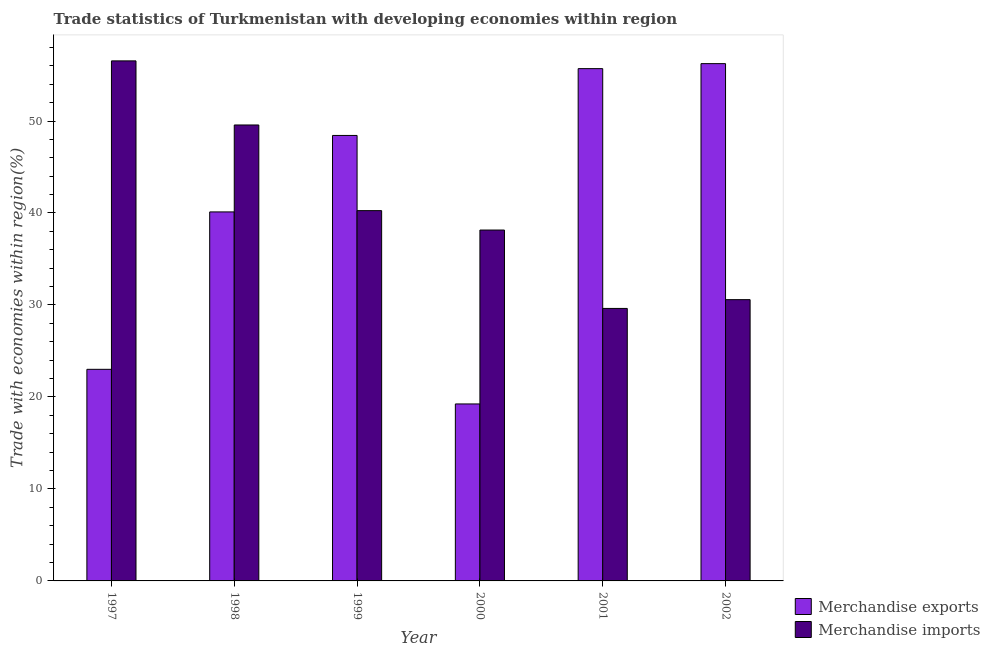How many different coloured bars are there?
Your answer should be very brief. 2. How many groups of bars are there?
Your answer should be very brief. 6. Are the number of bars on each tick of the X-axis equal?
Provide a short and direct response. Yes. What is the merchandise exports in 2000?
Provide a succinct answer. 19.24. Across all years, what is the maximum merchandise exports?
Your answer should be very brief. 56.24. Across all years, what is the minimum merchandise exports?
Your answer should be compact. 19.24. In which year was the merchandise exports minimum?
Provide a short and direct response. 2000. What is the total merchandise imports in the graph?
Offer a very short reply. 244.71. What is the difference between the merchandise exports in 1997 and that in 2001?
Your answer should be compact. -32.69. What is the difference between the merchandise imports in 2000 and the merchandise exports in 1998?
Offer a terse response. -11.42. What is the average merchandise imports per year?
Your answer should be very brief. 40.79. In how many years, is the merchandise imports greater than 46 %?
Ensure brevity in your answer.  2. What is the ratio of the merchandise imports in 1999 to that in 2000?
Your answer should be compact. 1.06. Is the merchandise exports in 1998 less than that in 2002?
Your answer should be compact. Yes. Is the difference between the merchandise imports in 1998 and 1999 greater than the difference between the merchandise exports in 1998 and 1999?
Your response must be concise. No. What is the difference between the highest and the second highest merchandise exports?
Your answer should be compact. 0.54. What is the difference between the highest and the lowest merchandise exports?
Provide a succinct answer. 37. In how many years, is the merchandise exports greater than the average merchandise exports taken over all years?
Your answer should be compact. 3. What does the 1st bar from the left in 2001 represents?
Provide a short and direct response. Merchandise exports. How many bars are there?
Your answer should be very brief. 12. Are all the bars in the graph horizontal?
Your answer should be very brief. No. Are the values on the major ticks of Y-axis written in scientific E-notation?
Your response must be concise. No. Does the graph contain any zero values?
Provide a succinct answer. No. Does the graph contain grids?
Provide a short and direct response. No. How many legend labels are there?
Offer a very short reply. 2. How are the legend labels stacked?
Offer a very short reply. Vertical. What is the title of the graph?
Your answer should be compact. Trade statistics of Turkmenistan with developing economies within region. What is the label or title of the X-axis?
Give a very brief answer. Year. What is the label or title of the Y-axis?
Offer a very short reply. Trade with economies within region(%). What is the Trade with economies within region(%) of Merchandise exports in 1997?
Provide a short and direct response. 23. What is the Trade with economies within region(%) in Merchandise imports in 1997?
Provide a short and direct response. 56.54. What is the Trade with economies within region(%) in Merchandise exports in 1998?
Keep it short and to the point. 40.12. What is the Trade with economies within region(%) in Merchandise imports in 1998?
Your answer should be compact. 49.57. What is the Trade with economies within region(%) in Merchandise exports in 1999?
Keep it short and to the point. 48.43. What is the Trade with economies within region(%) of Merchandise imports in 1999?
Your answer should be very brief. 40.26. What is the Trade with economies within region(%) of Merchandise exports in 2000?
Provide a short and direct response. 19.24. What is the Trade with economies within region(%) in Merchandise imports in 2000?
Your answer should be compact. 38.15. What is the Trade with economies within region(%) in Merchandise exports in 2001?
Your response must be concise. 55.69. What is the Trade with economies within region(%) of Merchandise imports in 2001?
Provide a succinct answer. 29.62. What is the Trade with economies within region(%) in Merchandise exports in 2002?
Provide a short and direct response. 56.24. What is the Trade with economies within region(%) of Merchandise imports in 2002?
Offer a very short reply. 30.58. Across all years, what is the maximum Trade with economies within region(%) in Merchandise exports?
Your answer should be compact. 56.24. Across all years, what is the maximum Trade with economies within region(%) of Merchandise imports?
Your answer should be very brief. 56.54. Across all years, what is the minimum Trade with economies within region(%) in Merchandise exports?
Provide a short and direct response. 19.24. Across all years, what is the minimum Trade with economies within region(%) of Merchandise imports?
Offer a terse response. 29.62. What is the total Trade with economies within region(%) in Merchandise exports in the graph?
Offer a terse response. 242.73. What is the total Trade with economies within region(%) in Merchandise imports in the graph?
Make the answer very short. 244.71. What is the difference between the Trade with economies within region(%) of Merchandise exports in 1997 and that in 1998?
Offer a very short reply. -17.11. What is the difference between the Trade with economies within region(%) of Merchandise imports in 1997 and that in 1998?
Keep it short and to the point. 6.97. What is the difference between the Trade with economies within region(%) in Merchandise exports in 1997 and that in 1999?
Offer a terse response. -25.43. What is the difference between the Trade with economies within region(%) of Merchandise imports in 1997 and that in 1999?
Your response must be concise. 16.28. What is the difference between the Trade with economies within region(%) in Merchandise exports in 1997 and that in 2000?
Make the answer very short. 3.76. What is the difference between the Trade with economies within region(%) in Merchandise imports in 1997 and that in 2000?
Your response must be concise. 18.39. What is the difference between the Trade with economies within region(%) in Merchandise exports in 1997 and that in 2001?
Give a very brief answer. -32.69. What is the difference between the Trade with economies within region(%) in Merchandise imports in 1997 and that in 2001?
Provide a short and direct response. 26.91. What is the difference between the Trade with economies within region(%) in Merchandise exports in 1997 and that in 2002?
Give a very brief answer. -33.23. What is the difference between the Trade with economies within region(%) in Merchandise imports in 1997 and that in 2002?
Provide a short and direct response. 25.96. What is the difference between the Trade with economies within region(%) of Merchandise exports in 1998 and that in 1999?
Provide a succinct answer. -8.31. What is the difference between the Trade with economies within region(%) in Merchandise imports in 1998 and that in 1999?
Provide a short and direct response. 9.31. What is the difference between the Trade with economies within region(%) of Merchandise exports in 1998 and that in 2000?
Your answer should be very brief. 20.88. What is the difference between the Trade with economies within region(%) in Merchandise imports in 1998 and that in 2000?
Ensure brevity in your answer.  11.42. What is the difference between the Trade with economies within region(%) of Merchandise exports in 1998 and that in 2001?
Provide a short and direct response. -15.58. What is the difference between the Trade with economies within region(%) in Merchandise imports in 1998 and that in 2001?
Your answer should be very brief. 19.94. What is the difference between the Trade with economies within region(%) of Merchandise exports in 1998 and that in 2002?
Offer a terse response. -16.12. What is the difference between the Trade with economies within region(%) of Merchandise imports in 1998 and that in 2002?
Ensure brevity in your answer.  18.99. What is the difference between the Trade with economies within region(%) of Merchandise exports in 1999 and that in 2000?
Offer a terse response. 29.19. What is the difference between the Trade with economies within region(%) in Merchandise imports in 1999 and that in 2000?
Your answer should be compact. 2.11. What is the difference between the Trade with economies within region(%) of Merchandise exports in 1999 and that in 2001?
Provide a succinct answer. -7.26. What is the difference between the Trade with economies within region(%) of Merchandise imports in 1999 and that in 2001?
Give a very brief answer. 10.63. What is the difference between the Trade with economies within region(%) in Merchandise exports in 1999 and that in 2002?
Offer a very short reply. -7.81. What is the difference between the Trade with economies within region(%) in Merchandise imports in 1999 and that in 2002?
Your response must be concise. 9.68. What is the difference between the Trade with economies within region(%) in Merchandise exports in 2000 and that in 2001?
Give a very brief answer. -36.45. What is the difference between the Trade with economies within region(%) of Merchandise imports in 2000 and that in 2001?
Give a very brief answer. 8.52. What is the difference between the Trade with economies within region(%) of Merchandise exports in 2000 and that in 2002?
Give a very brief answer. -37. What is the difference between the Trade with economies within region(%) of Merchandise imports in 2000 and that in 2002?
Your answer should be compact. 7.57. What is the difference between the Trade with economies within region(%) of Merchandise exports in 2001 and that in 2002?
Ensure brevity in your answer.  -0.54. What is the difference between the Trade with economies within region(%) in Merchandise imports in 2001 and that in 2002?
Provide a succinct answer. -0.96. What is the difference between the Trade with economies within region(%) of Merchandise exports in 1997 and the Trade with economies within region(%) of Merchandise imports in 1998?
Provide a succinct answer. -26.56. What is the difference between the Trade with economies within region(%) of Merchandise exports in 1997 and the Trade with economies within region(%) of Merchandise imports in 1999?
Your answer should be very brief. -17.25. What is the difference between the Trade with economies within region(%) in Merchandise exports in 1997 and the Trade with economies within region(%) in Merchandise imports in 2000?
Offer a very short reply. -15.14. What is the difference between the Trade with economies within region(%) of Merchandise exports in 1997 and the Trade with economies within region(%) of Merchandise imports in 2001?
Provide a short and direct response. -6.62. What is the difference between the Trade with economies within region(%) in Merchandise exports in 1997 and the Trade with economies within region(%) in Merchandise imports in 2002?
Provide a succinct answer. -7.57. What is the difference between the Trade with economies within region(%) of Merchandise exports in 1998 and the Trade with economies within region(%) of Merchandise imports in 1999?
Offer a terse response. -0.14. What is the difference between the Trade with economies within region(%) in Merchandise exports in 1998 and the Trade with economies within region(%) in Merchandise imports in 2000?
Make the answer very short. 1.97. What is the difference between the Trade with economies within region(%) of Merchandise exports in 1998 and the Trade with economies within region(%) of Merchandise imports in 2001?
Ensure brevity in your answer.  10.49. What is the difference between the Trade with economies within region(%) in Merchandise exports in 1998 and the Trade with economies within region(%) in Merchandise imports in 2002?
Your answer should be very brief. 9.54. What is the difference between the Trade with economies within region(%) of Merchandise exports in 1999 and the Trade with economies within region(%) of Merchandise imports in 2000?
Make the answer very short. 10.28. What is the difference between the Trade with economies within region(%) in Merchandise exports in 1999 and the Trade with economies within region(%) in Merchandise imports in 2001?
Ensure brevity in your answer.  18.81. What is the difference between the Trade with economies within region(%) of Merchandise exports in 1999 and the Trade with economies within region(%) of Merchandise imports in 2002?
Provide a succinct answer. 17.85. What is the difference between the Trade with economies within region(%) of Merchandise exports in 2000 and the Trade with economies within region(%) of Merchandise imports in 2001?
Your response must be concise. -10.38. What is the difference between the Trade with economies within region(%) in Merchandise exports in 2000 and the Trade with economies within region(%) in Merchandise imports in 2002?
Offer a terse response. -11.34. What is the difference between the Trade with economies within region(%) in Merchandise exports in 2001 and the Trade with economies within region(%) in Merchandise imports in 2002?
Provide a short and direct response. 25.12. What is the average Trade with economies within region(%) in Merchandise exports per year?
Give a very brief answer. 40.45. What is the average Trade with economies within region(%) in Merchandise imports per year?
Your answer should be compact. 40.79. In the year 1997, what is the difference between the Trade with economies within region(%) in Merchandise exports and Trade with economies within region(%) in Merchandise imports?
Give a very brief answer. -33.53. In the year 1998, what is the difference between the Trade with economies within region(%) of Merchandise exports and Trade with economies within region(%) of Merchandise imports?
Provide a succinct answer. -9.45. In the year 1999, what is the difference between the Trade with economies within region(%) of Merchandise exports and Trade with economies within region(%) of Merchandise imports?
Your answer should be compact. 8.17. In the year 2000, what is the difference between the Trade with economies within region(%) in Merchandise exports and Trade with economies within region(%) in Merchandise imports?
Your answer should be very brief. -18.91. In the year 2001, what is the difference between the Trade with economies within region(%) of Merchandise exports and Trade with economies within region(%) of Merchandise imports?
Make the answer very short. 26.07. In the year 2002, what is the difference between the Trade with economies within region(%) in Merchandise exports and Trade with economies within region(%) in Merchandise imports?
Offer a terse response. 25.66. What is the ratio of the Trade with economies within region(%) of Merchandise exports in 1997 to that in 1998?
Give a very brief answer. 0.57. What is the ratio of the Trade with economies within region(%) in Merchandise imports in 1997 to that in 1998?
Your response must be concise. 1.14. What is the ratio of the Trade with economies within region(%) in Merchandise exports in 1997 to that in 1999?
Your answer should be compact. 0.47. What is the ratio of the Trade with economies within region(%) of Merchandise imports in 1997 to that in 1999?
Offer a very short reply. 1.4. What is the ratio of the Trade with economies within region(%) of Merchandise exports in 1997 to that in 2000?
Your answer should be very brief. 1.2. What is the ratio of the Trade with economies within region(%) in Merchandise imports in 1997 to that in 2000?
Your answer should be very brief. 1.48. What is the ratio of the Trade with economies within region(%) of Merchandise exports in 1997 to that in 2001?
Give a very brief answer. 0.41. What is the ratio of the Trade with economies within region(%) of Merchandise imports in 1997 to that in 2001?
Offer a terse response. 1.91. What is the ratio of the Trade with economies within region(%) in Merchandise exports in 1997 to that in 2002?
Ensure brevity in your answer.  0.41. What is the ratio of the Trade with economies within region(%) in Merchandise imports in 1997 to that in 2002?
Keep it short and to the point. 1.85. What is the ratio of the Trade with economies within region(%) of Merchandise exports in 1998 to that in 1999?
Offer a terse response. 0.83. What is the ratio of the Trade with economies within region(%) in Merchandise imports in 1998 to that in 1999?
Keep it short and to the point. 1.23. What is the ratio of the Trade with economies within region(%) of Merchandise exports in 1998 to that in 2000?
Your answer should be very brief. 2.09. What is the ratio of the Trade with economies within region(%) of Merchandise imports in 1998 to that in 2000?
Give a very brief answer. 1.3. What is the ratio of the Trade with economies within region(%) of Merchandise exports in 1998 to that in 2001?
Offer a very short reply. 0.72. What is the ratio of the Trade with economies within region(%) in Merchandise imports in 1998 to that in 2001?
Provide a short and direct response. 1.67. What is the ratio of the Trade with economies within region(%) in Merchandise exports in 1998 to that in 2002?
Keep it short and to the point. 0.71. What is the ratio of the Trade with economies within region(%) of Merchandise imports in 1998 to that in 2002?
Keep it short and to the point. 1.62. What is the ratio of the Trade with economies within region(%) in Merchandise exports in 1999 to that in 2000?
Your response must be concise. 2.52. What is the ratio of the Trade with economies within region(%) in Merchandise imports in 1999 to that in 2000?
Your answer should be very brief. 1.06. What is the ratio of the Trade with economies within region(%) in Merchandise exports in 1999 to that in 2001?
Keep it short and to the point. 0.87. What is the ratio of the Trade with economies within region(%) of Merchandise imports in 1999 to that in 2001?
Offer a terse response. 1.36. What is the ratio of the Trade with economies within region(%) of Merchandise exports in 1999 to that in 2002?
Your answer should be very brief. 0.86. What is the ratio of the Trade with economies within region(%) of Merchandise imports in 1999 to that in 2002?
Offer a terse response. 1.32. What is the ratio of the Trade with economies within region(%) in Merchandise exports in 2000 to that in 2001?
Provide a succinct answer. 0.35. What is the ratio of the Trade with economies within region(%) in Merchandise imports in 2000 to that in 2001?
Make the answer very short. 1.29. What is the ratio of the Trade with economies within region(%) of Merchandise exports in 2000 to that in 2002?
Your answer should be compact. 0.34. What is the ratio of the Trade with economies within region(%) of Merchandise imports in 2000 to that in 2002?
Make the answer very short. 1.25. What is the ratio of the Trade with economies within region(%) of Merchandise imports in 2001 to that in 2002?
Your answer should be very brief. 0.97. What is the difference between the highest and the second highest Trade with economies within region(%) in Merchandise exports?
Give a very brief answer. 0.54. What is the difference between the highest and the second highest Trade with economies within region(%) in Merchandise imports?
Ensure brevity in your answer.  6.97. What is the difference between the highest and the lowest Trade with economies within region(%) of Merchandise exports?
Ensure brevity in your answer.  37. What is the difference between the highest and the lowest Trade with economies within region(%) of Merchandise imports?
Offer a very short reply. 26.91. 